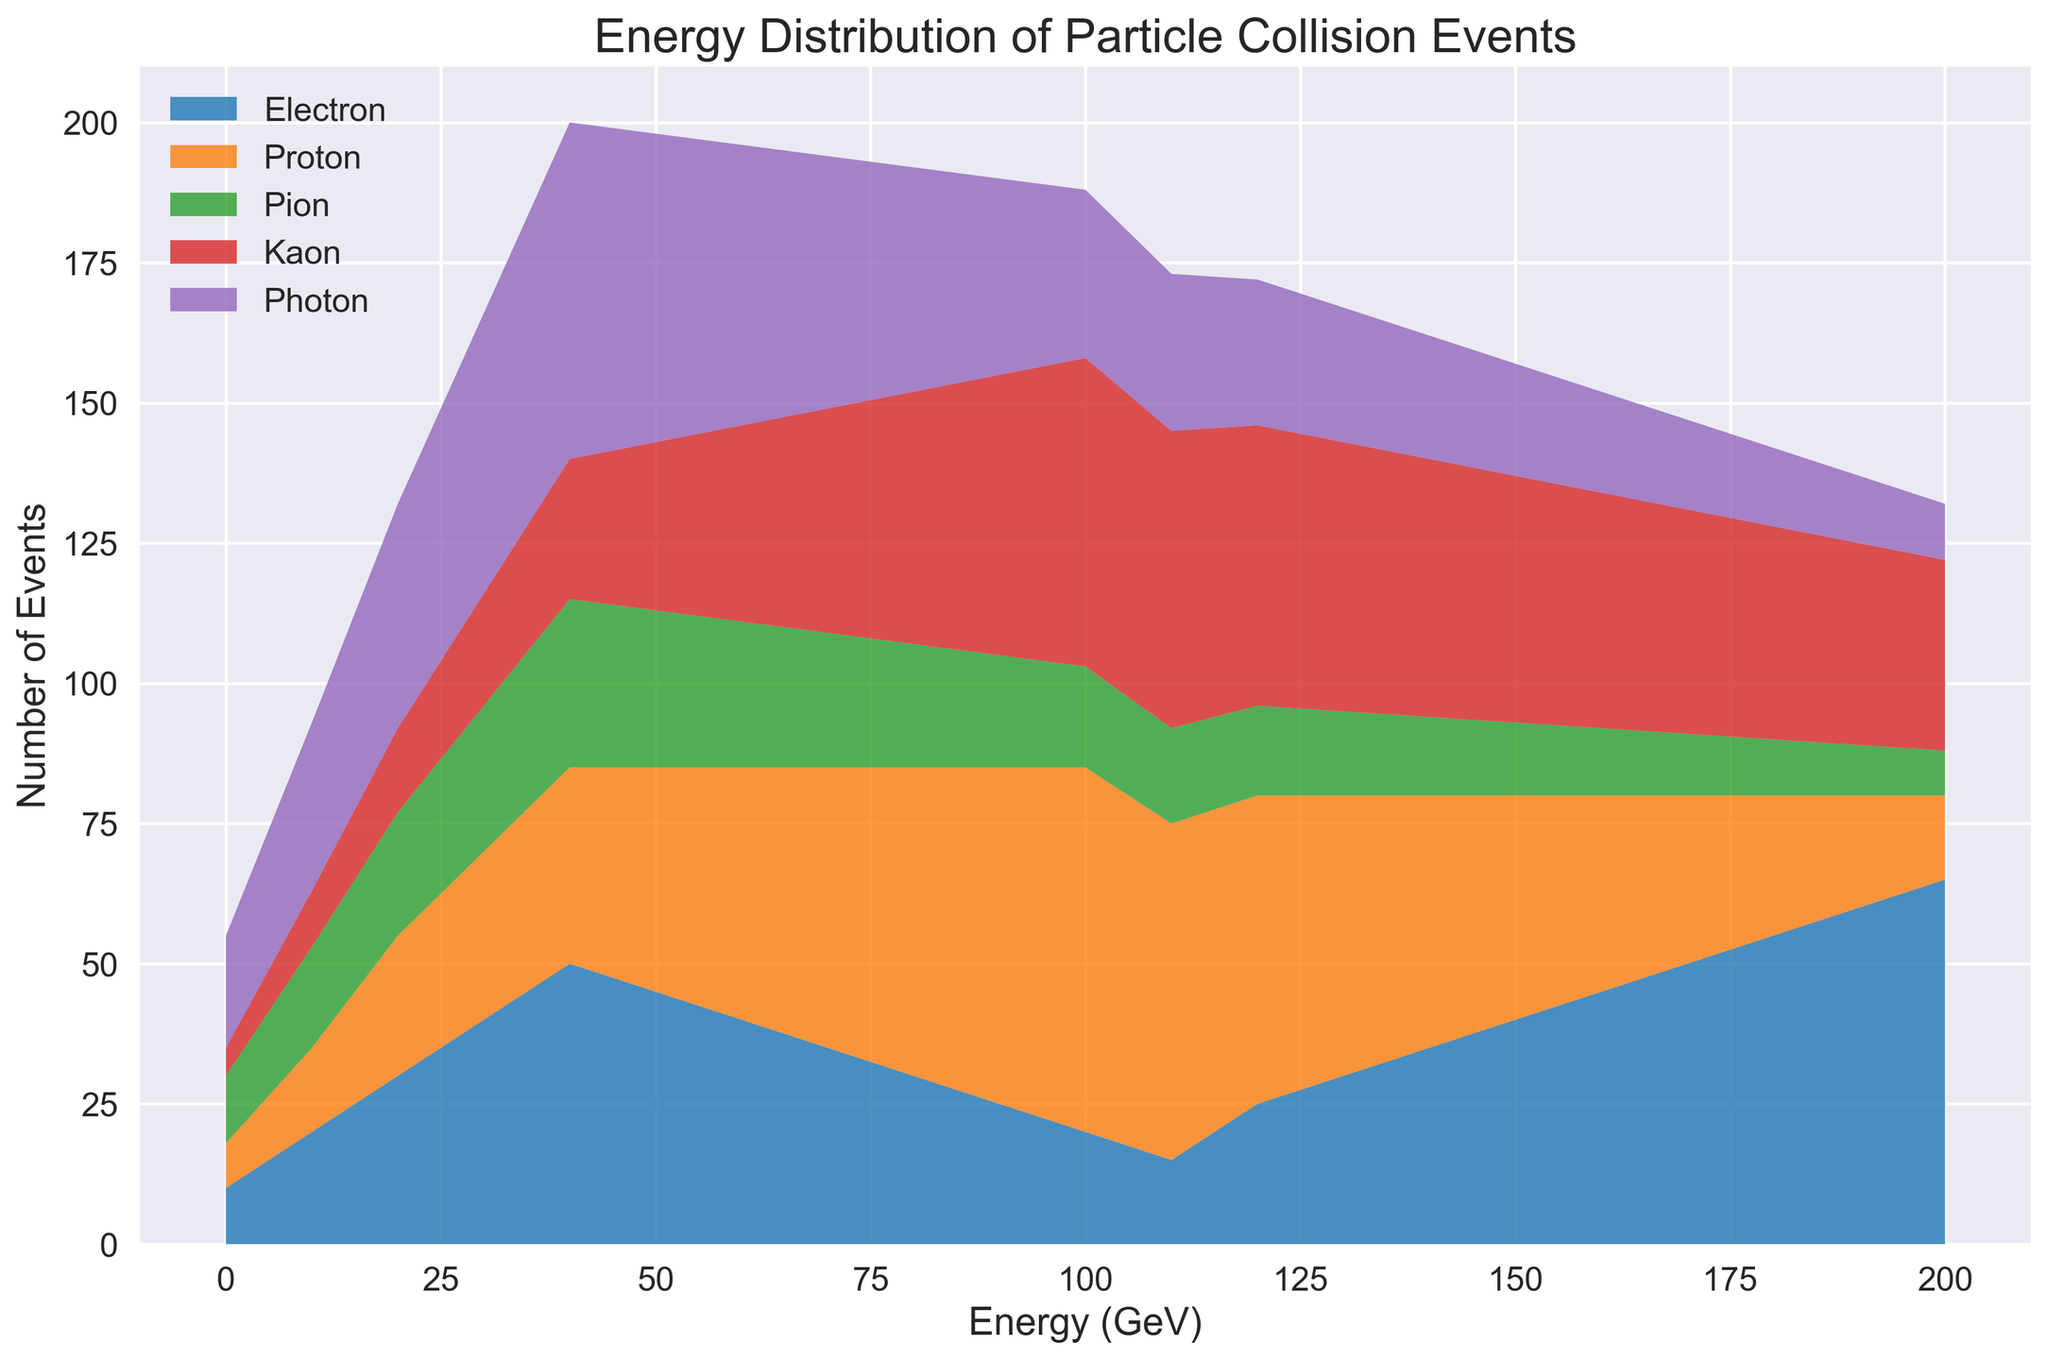What is the total number of events for the Photon type at 100 GeV energy? Identify the Photon data series in the plot, locate the value at 100 GeV energy on the x-axis, and read off the value from the graph, which is a height of bars at 100 GeV for Photons, summing up to 30.
Answer: 30 Which particle type shows the highest number of events at 50 GeV energy? Locate the 50 GeV mark on the x-axis, observe the heights of the stacks for each particle type, and identify which one is the tallest. The tallest stack at 50 GeV is for the Photon type.
Answer: Photon At what energy level does the Proton type peak? Examine the plot and trace the Proton type (usually with its own unique color), find the peak value which is the maximum height reached by the Proton stack on the graph. This occurs at 100 GeV.
Answer: 100 GeV How does the number of Electron events change from 30 GeV to 70 GeV? Compare the stack height at 30 GeV, which is 40, with the stack height at 70 GeV, which is 35, and calculate the difference. The change is 40 - 35 = +5 events.
Answer: Decreases by 5 What is the sum of the number of events for Kaons and Pions at 150 GeV? For both Kaons and Pions, locate the height of their stacks at 150 GeV, which are 44 and 13 respectively. Sum these two values, 44 + 13 = 57.
Answer: 57 Which particle types exhibit a decrease in the number of events from 60 GeV to 160 GeV? Examine the plot for each particle type from 60 GeV to 160 GeV. Electron (40 to 45), Proton (45 to 35), Pion (26 to 12), Kaon (35 to 42), Photon (50 to 18). Proton, Pion, and Photon decrease.
Answer: Proton, Pion, Photon What is the difference in the number of Proton events at 90 GeV and 130 GeV? Read the number of events for Protons at both 90 GeV (60) and 130 GeV (50), and calculate the difference. The difference is 60 - 50 = 10.
Answer: 10 At 200 GeV, which particle type has the lowest number of events, and what is that number? Locate the 200 GeV mark, observe which stack height is the shortest, in this case, the Kaon, and read off the value, which is 8.
Answer: Kaon, 8 How does the total number of events change from 0 GeV to 200 GeV? Sum the stack heights at 0 GeV (10+8+12+5+20=55) and at 200 GeV (65+15+8+34+10=132), then find the difference. 132 - 55 = 77.
Answer: Increases by 77 Which two particle types have the closest number of events at 170 GeV and what are those values? Locate the 170 GeV mark, compare the stack heights of each particle type, and find the closest values. Proton (30) and Kaon (40) are the closest with a difference of 10.
Answer: Proton (30) and Kaon (40) 